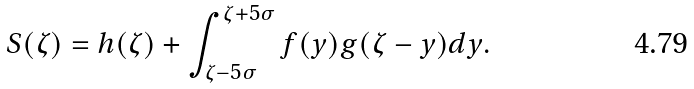Convert formula to latex. <formula><loc_0><loc_0><loc_500><loc_500>S ( \zeta ) = h ( \zeta ) + \int _ { \zeta - 5 \sigma } ^ { \zeta + 5 \sigma } { f ( y ) g ( \zeta - y ) d y } .</formula> 